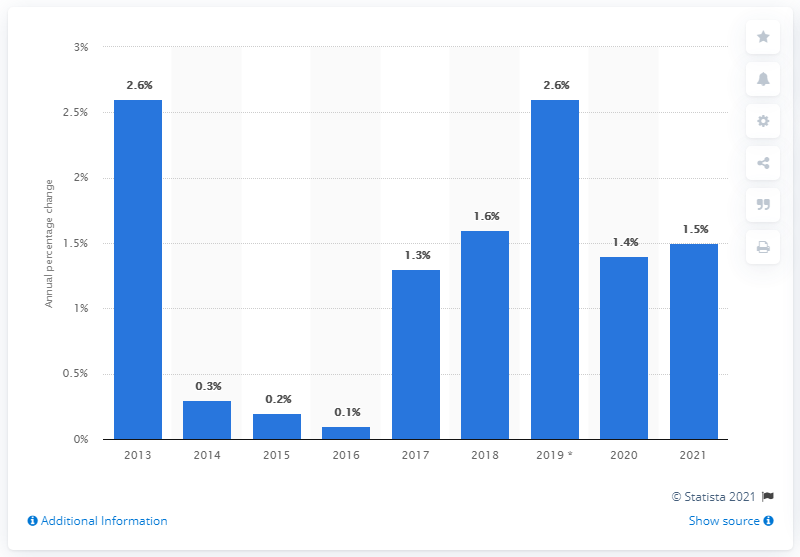Point out several critical features in this image. The HICP is expected to grow by an estimated 1.5% in 2020. 